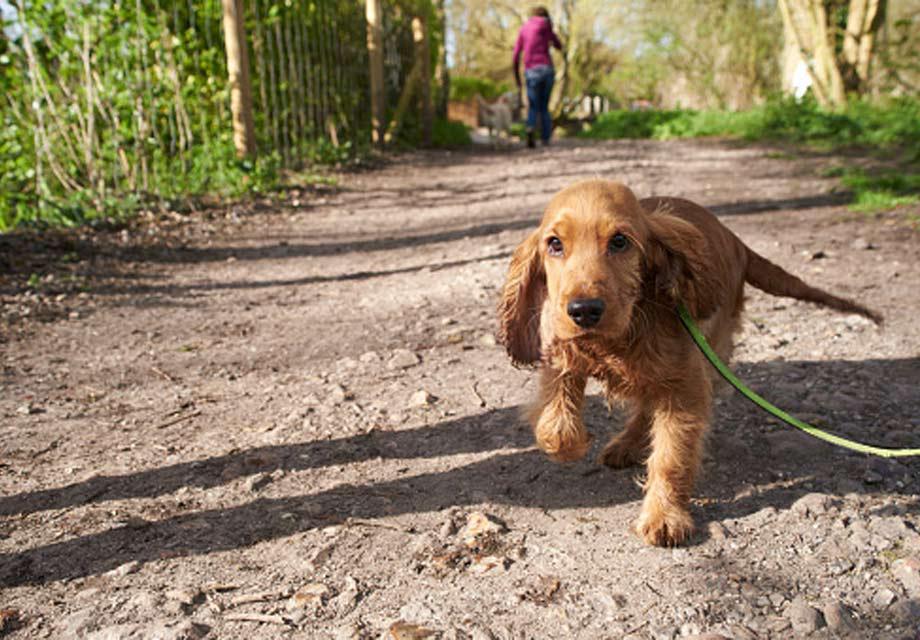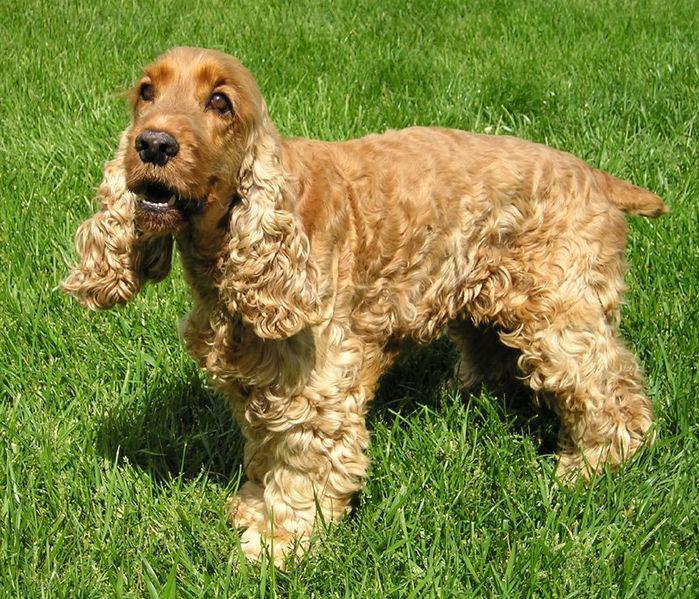The first image is the image on the left, the second image is the image on the right. Evaluate the accuracy of this statement regarding the images: "At least two dogs are sitting int he grass.". Is it true? Answer yes or no. No. The first image is the image on the left, the second image is the image on the right. Assess this claim about the two images: "An image includes a white dog with black ears, and includes more than one dog.". Correct or not? Answer yes or no. No. 